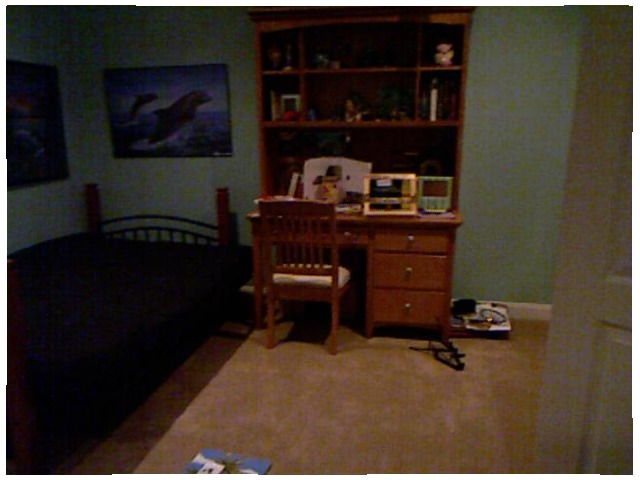<image>
Is there a chair next to the desk? No. The chair is not positioned next to the desk. They are located in different areas of the scene. 